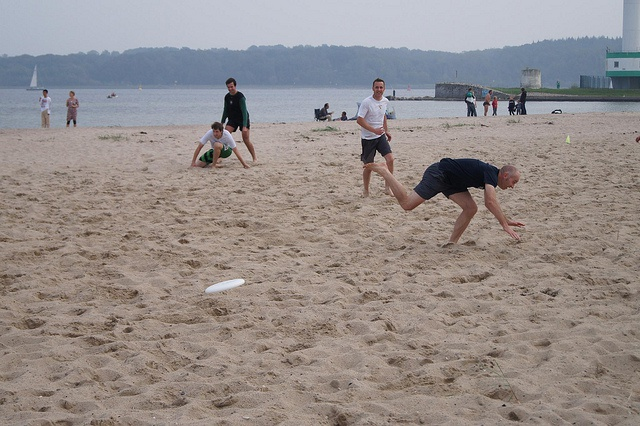Describe the objects in this image and their specific colors. I can see people in darkgray, black, brown, gray, and maroon tones, people in darkgray, black, brown, and gray tones, people in darkgray, gray, and black tones, people in darkgray, black, gray, maroon, and brown tones, and people in darkgray and gray tones in this image. 